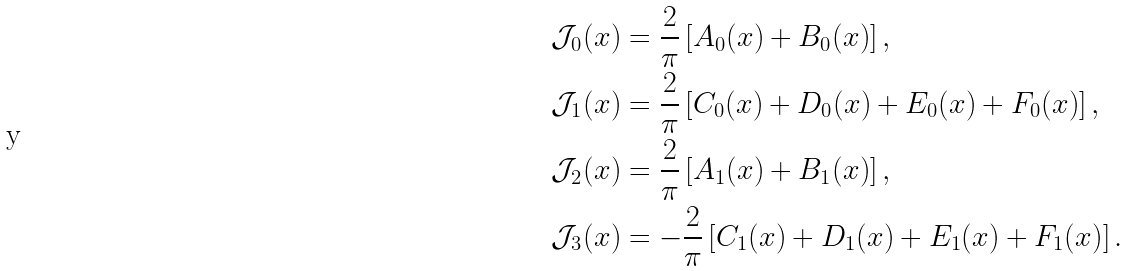<formula> <loc_0><loc_0><loc_500><loc_500>\mathcal { J } _ { 0 } ( x ) & = \frac { 2 } { \pi } \left [ A _ { 0 } ( x ) + B _ { 0 } ( x ) \right ] , \\ \mathcal { J } _ { 1 } ( x ) & = \frac { 2 } { \pi } \left [ C _ { 0 } ( x ) + D _ { 0 } ( x ) + E _ { 0 } ( x ) + F _ { 0 } ( x ) \right ] , \\ \mathcal { J } _ { 2 } ( x ) & = \frac { 2 } { \pi } \left [ A _ { 1 } ( x ) + B _ { 1 } ( x ) \right ] , \\ \mathcal { J } _ { 3 } ( x ) & = - \frac { 2 } { \pi } \left [ C _ { 1 } ( x ) + D _ { 1 } ( x ) + E _ { 1 } ( x ) + F _ { 1 } ( x ) \right ] .</formula> 